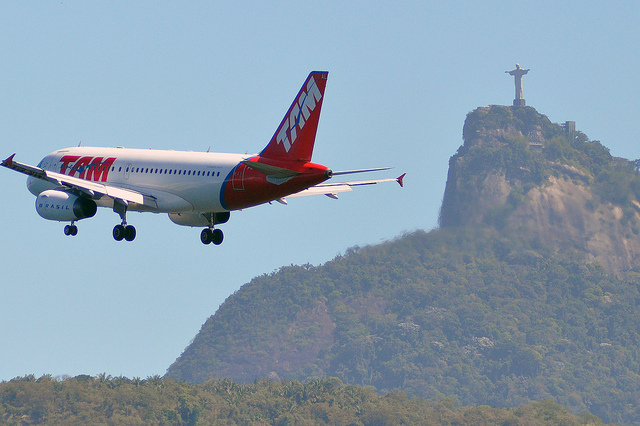If there were birds in the sky, would they be closer to the airplane or the statue? Although there are no birds visible in the current image, hypothetically speaking, the proximity of birds to either the airplane or the statue would depend on their specific location in the sky within the image. They could be nearer to the plane, given its lower altitude, or closer to the statue in the background. 